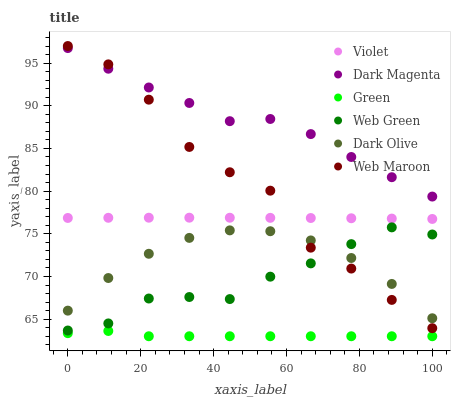Does Green have the minimum area under the curve?
Answer yes or no. Yes. Does Dark Magenta have the maximum area under the curve?
Answer yes or no. Yes. Does Dark Olive have the minimum area under the curve?
Answer yes or no. No. Does Dark Olive have the maximum area under the curve?
Answer yes or no. No. Is Violet the smoothest?
Answer yes or no. Yes. Is Web Maroon the roughest?
Answer yes or no. Yes. Is Dark Olive the smoothest?
Answer yes or no. No. Is Dark Olive the roughest?
Answer yes or no. No. Does Green have the lowest value?
Answer yes or no. Yes. Does Dark Olive have the lowest value?
Answer yes or no. No. Does Web Maroon have the highest value?
Answer yes or no. Yes. Does Dark Olive have the highest value?
Answer yes or no. No. Is Green less than Web Maroon?
Answer yes or no. Yes. Is Violet greater than Dark Olive?
Answer yes or no. Yes. Does Web Maroon intersect Dark Olive?
Answer yes or no. Yes. Is Web Maroon less than Dark Olive?
Answer yes or no. No. Is Web Maroon greater than Dark Olive?
Answer yes or no. No. Does Green intersect Web Maroon?
Answer yes or no. No. 